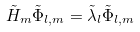Convert formula to latex. <formula><loc_0><loc_0><loc_500><loc_500>\tilde { H } _ { m } \tilde { \Phi } _ { l , m } = \tilde { \lambda } _ { l } \tilde { \Phi } _ { l , m }</formula> 